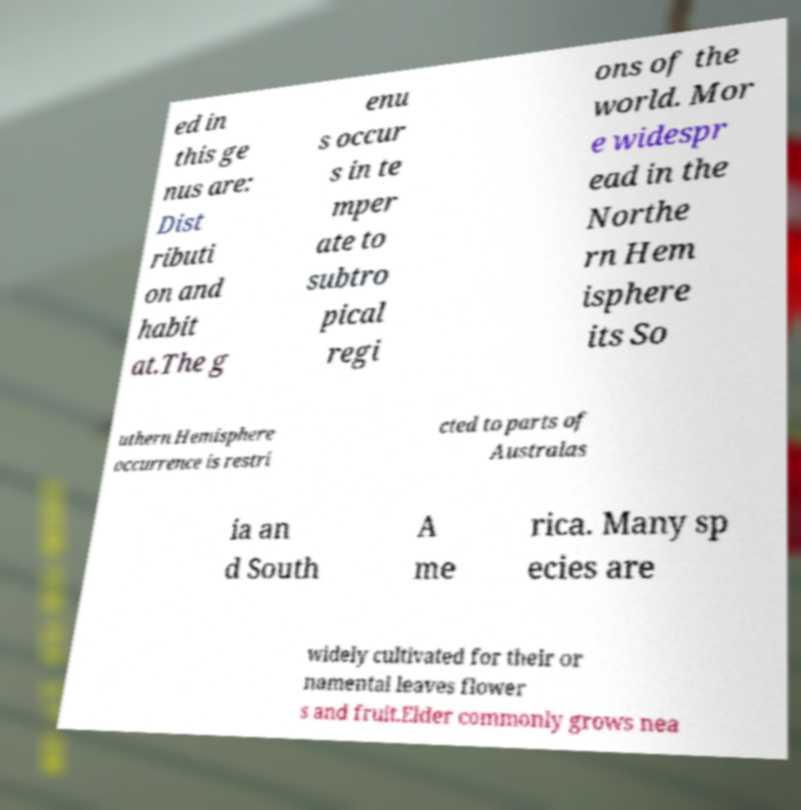Please read and relay the text visible in this image. What does it say? ed in this ge nus are: Dist ributi on and habit at.The g enu s occur s in te mper ate to subtro pical regi ons of the world. Mor e widespr ead in the Northe rn Hem isphere its So uthern Hemisphere occurrence is restri cted to parts of Australas ia an d South A me rica. Many sp ecies are widely cultivated for their or namental leaves flower s and fruit.Elder commonly grows nea 